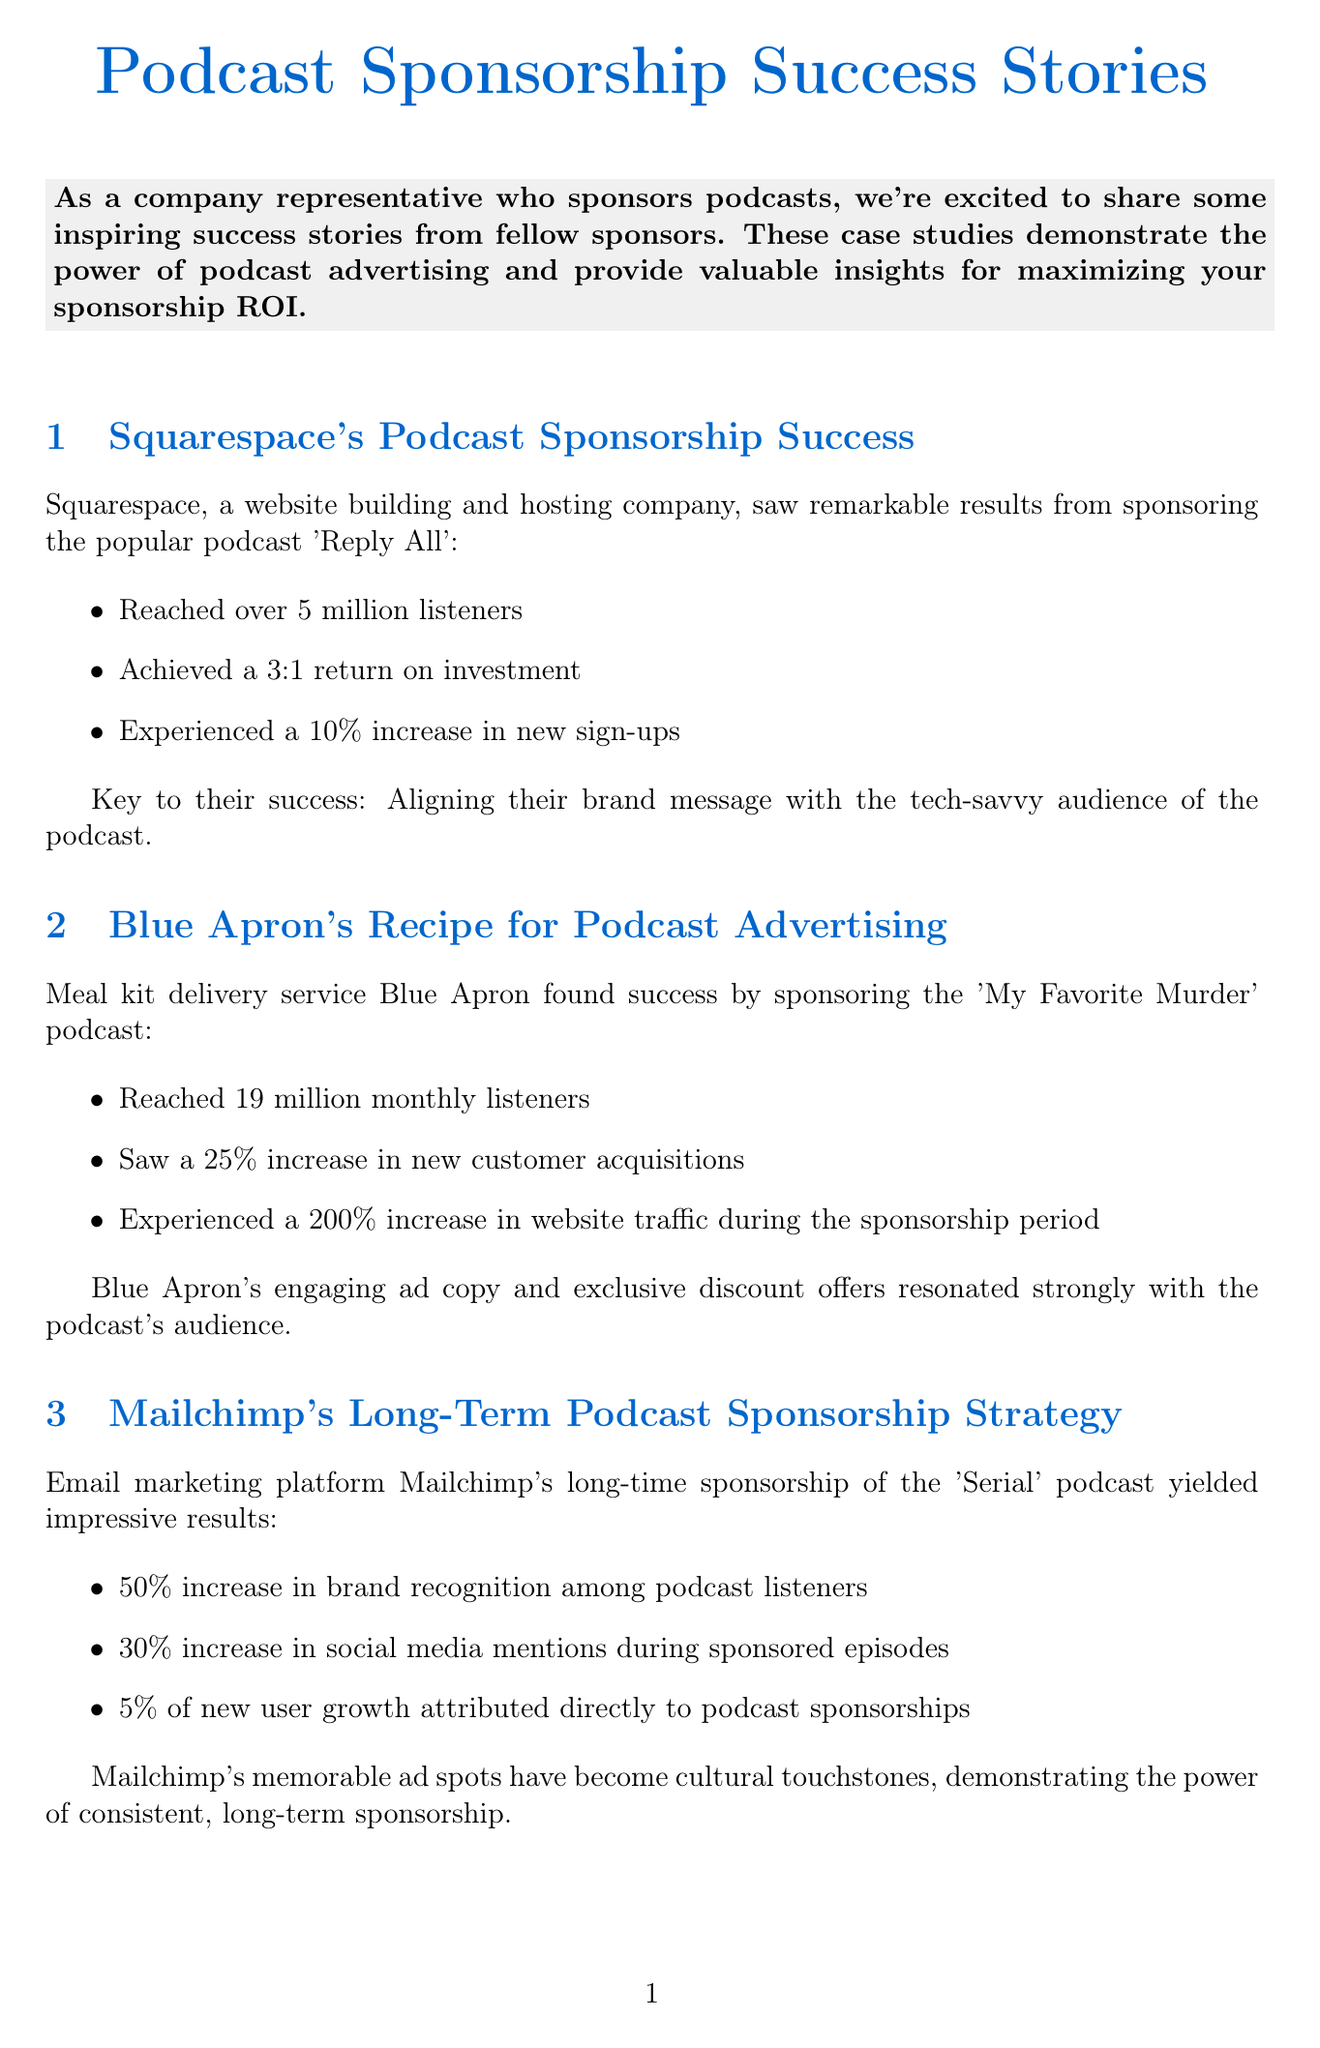What was Squarespace's increase in new sign-ups? The document states that Squarespace experienced a 10% increase in new sign-ups after sponsoring 'Reply All'.
Answer: 10% How many listeners did Blue Apron reach? The document mentions that Blue Apron reached 19 million monthly listeners by sponsoring 'My Favorite Murder'.
Answer: 19 million What was the return on investment for Squarespace? The document highlights that Squarespace achieved a 3:1 return on investment from their podcast sponsorship.
Answer: 3:1 What percentage did ZipRecruiter improve brand recall by? The document indicates that ZipRecruiter's brand recall improved by 60% among podcast listeners.
Answer: 60% What is one of the key sponsorship tips mentioned? The document lists various tips, one of which is to choose podcasts that align with your target audience demographics.
Answer: Choose podcasts that align with your target audience demographics What percentage of new user growth did Mailchimp attribute to podcast sponsorships? According to the document, Mailchimp attributed 5% of its new user growth directly to podcast sponsorships.
Answer: 5% How much did Casper's sales increase? The document states that Casper saw a 15% increase in sales through podcast sponsorships.
Answer: 15% Which podcast did Mailchimp sponsor? The document mentions that Mailchimp has been a long-time sponsor of the 'Serial' podcast.
Answer: Serial What increase in website traffic did Blue Apron experience during their sponsorship? The document states that Blue Apron experienced a 200% increase in website traffic during the sponsorship period.
Answer: 200% 